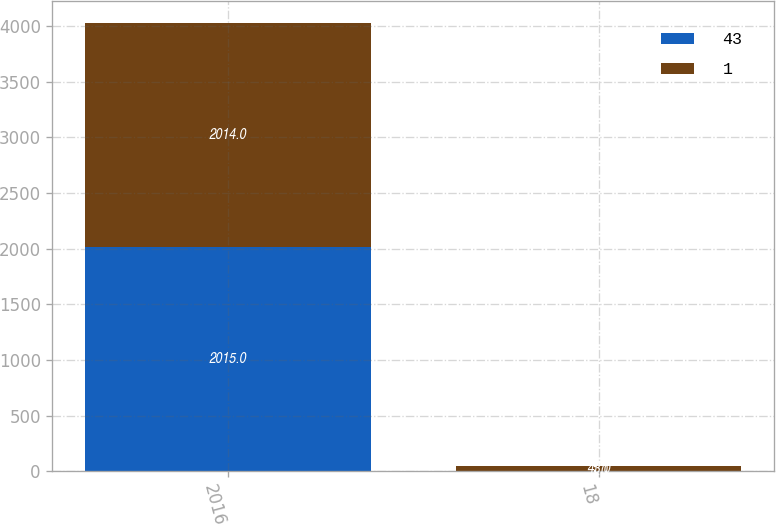Convert chart. <chart><loc_0><loc_0><loc_500><loc_500><stacked_bar_chart><ecel><fcel>2016<fcel>18<nl><fcel>43<fcel>2015<fcel>1<nl><fcel>1<fcel>2014<fcel>43<nl></chart> 